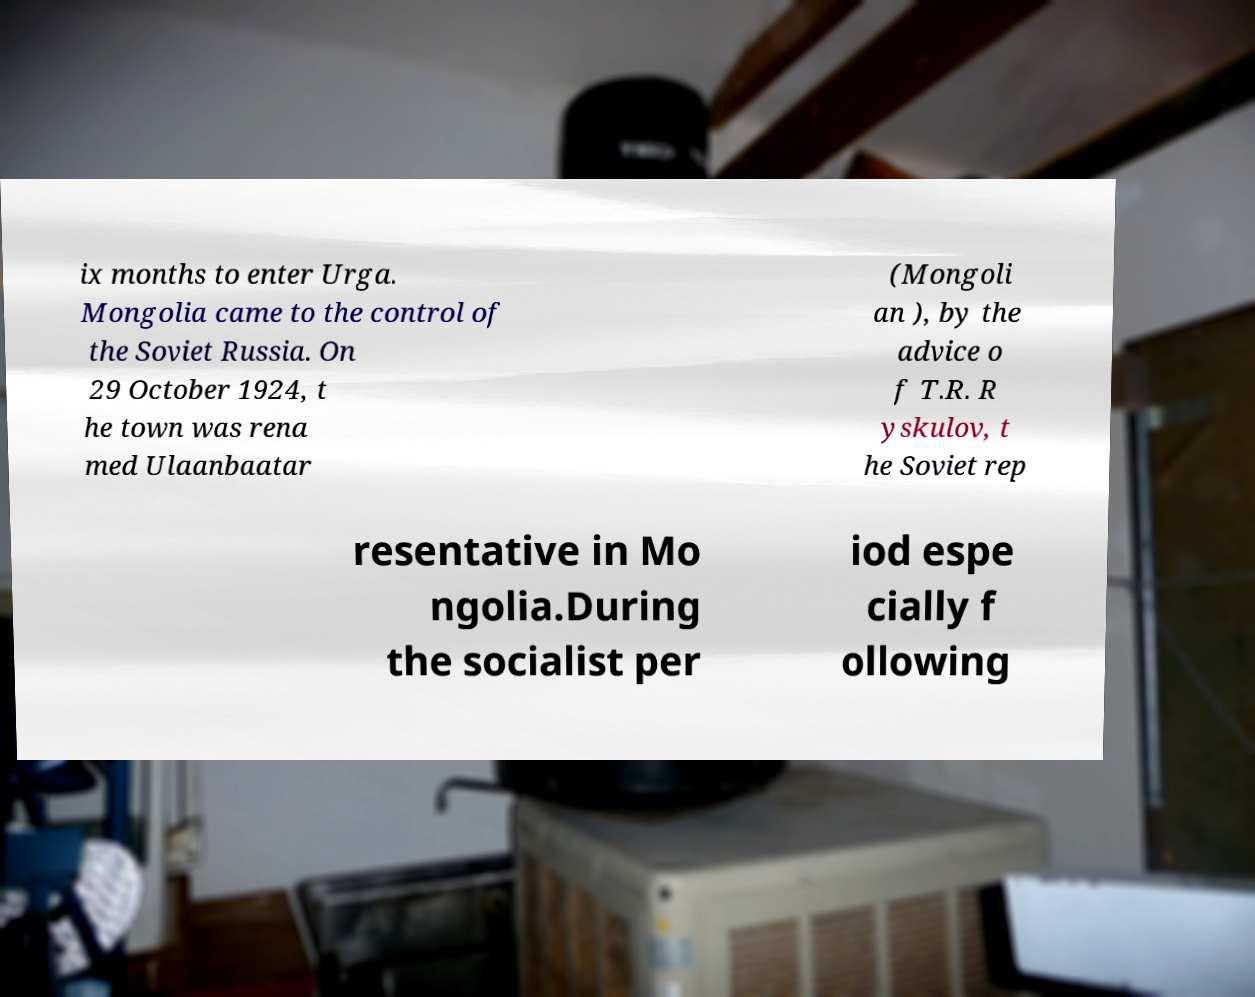Could you assist in decoding the text presented in this image and type it out clearly? ix months to enter Urga. Mongolia came to the control of the Soviet Russia. On 29 October 1924, t he town was rena med Ulaanbaatar (Mongoli an ), by the advice o f T.R. R yskulov, t he Soviet rep resentative in Mo ngolia.During the socialist per iod espe cially f ollowing 